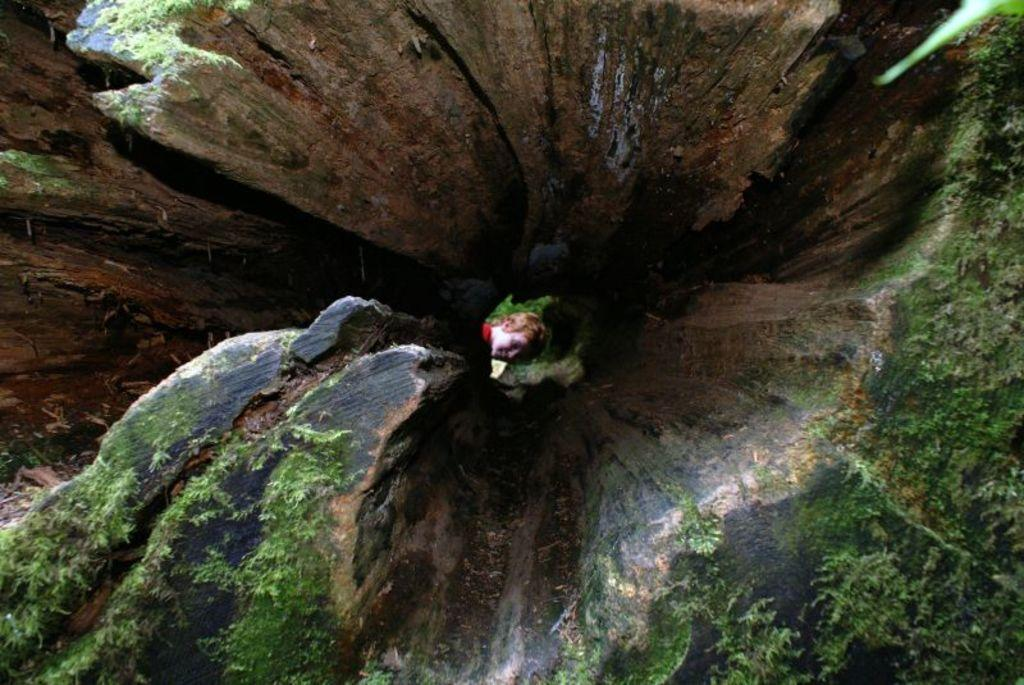What is the main subject of the image? The main subject of the image is a tree trunk. Are there any specific features of the tree trunk? Yes, there is a hole in the tree trunk. What can be seen inside the hole? A human face is visible in the hole. What type of roof can be seen on top of the sea in the image? There is no roof or sea present in the image; it features a tree trunk with a hole and a human face. 